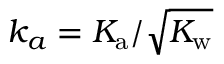<formula> <loc_0><loc_0><loc_500><loc_500>{ k _ { a } = K _ { a } / \sqrt { K _ { w } } }</formula> 